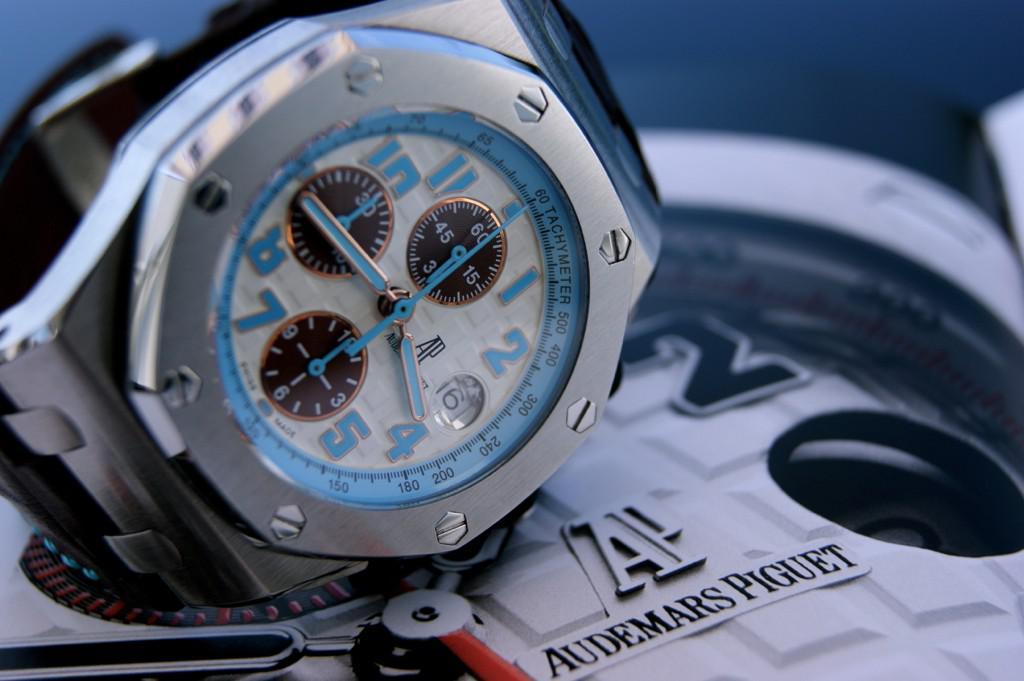What number is the small hand on?
Provide a short and direct response. 4. What time is it?
Ensure brevity in your answer.  3:45. 